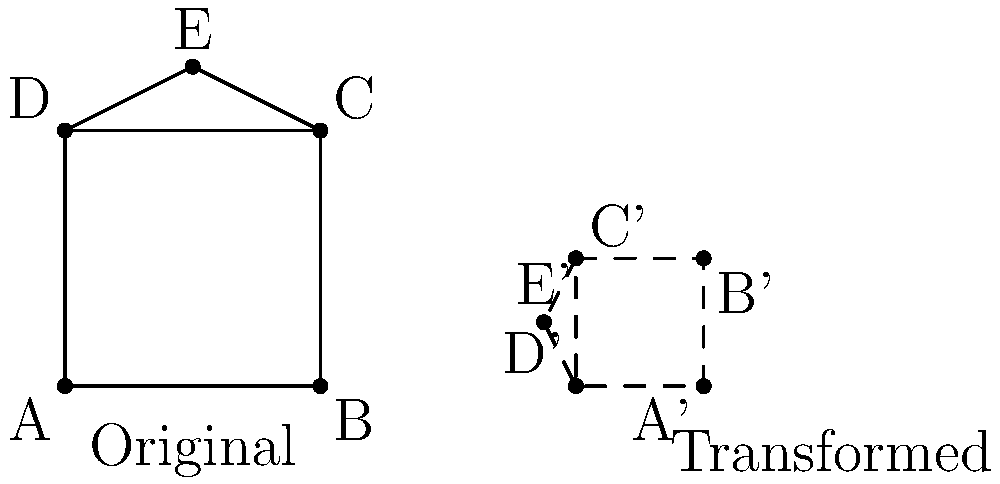You're working on a sketch for your stand-up routine, and you decide to create a simple caricature of Jerry Seinfeld as a square with a triangular hairdo. After drawing it, you apply the following transformations in order: scale by a factor of 0.5, rotate 90° clockwise, and translate 5 units to the right. What is the area of the transformed caricature compared to the original? Let's approach this step-by-step:

1) The original caricature consists of a square with a triangular "hairdo" on top.

2) The transformations applied are:
   a) Scale by 0.5
   b) Rotate 90° clockwise
   c) Translate 5 units to the right

3) The scaling transformation affects the area:
   - When we scale by a factor of $k$, the area is multiplied by $k^2$
   - Here, $k = 0.5$, so the area is multiplied by $(0.5)^2 = 0.25$

4) The rotation and translation do not affect the area of the shape.

5) Therefore, the area of the transformed caricature is 0.25 times the area of the original.

6) We can express this as a fraction: $\frac{1}{4}$

So, the transformed caricature has $\frac{1}{4}$ the area of the original.
Answer: $\frac{1}{4}$ 